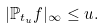Convert formula to latex. <formula><loc_0><loc_0><loc_500><loc_500>| \mathbb { P } _ { t _ { u } } f | _ { \infty } \leq u .</formula> 